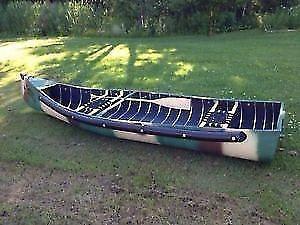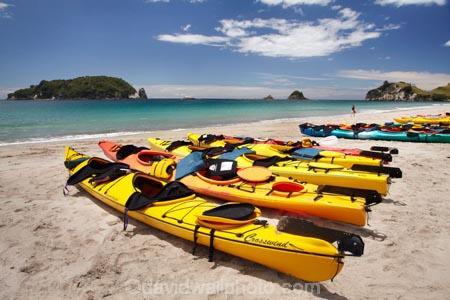The first image is the image on the left, the second image is the image on the right. Evaluate the accuracy of this statement regarding the images: "the image on the righ contains humans". Is it true? Answer yes or no. No. 